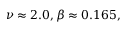Convert formula to latex. <formula><loc_0><loc_0><loc_500><loc_500>\nu \approx 2 . 0 , \beta \approx 0 . 1 6 5 ,</formula> 